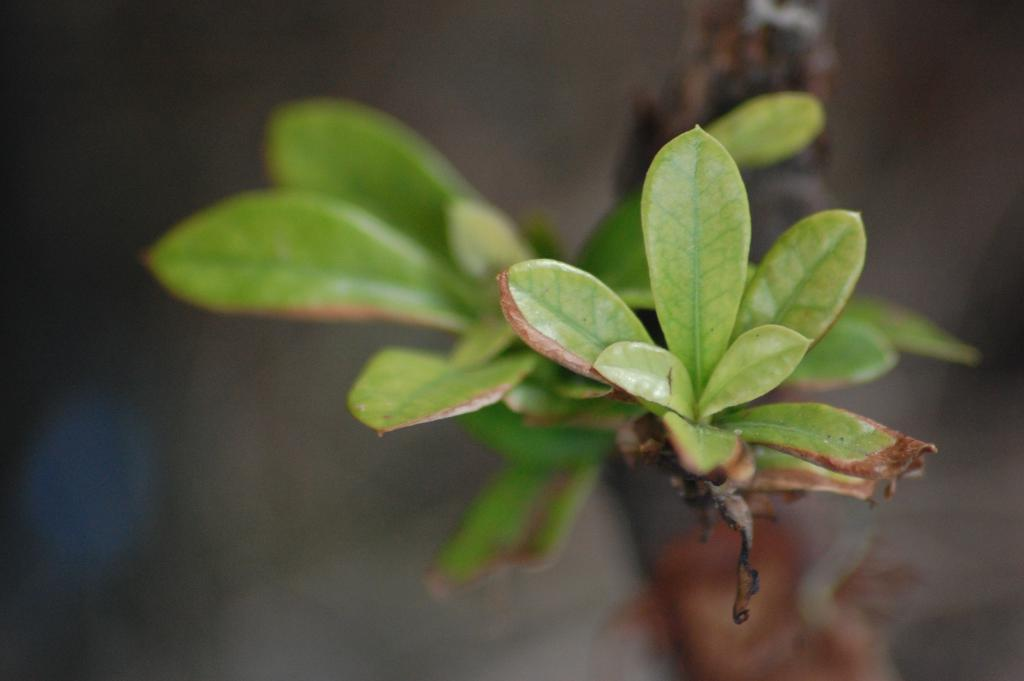What is present in the image? There is a plant in the image. What color is the plant? The plant is green in color. Can you describe the background of the image? The background of the image is blurred. How does the plant help with expansion in the image? The plant does not help with expansion in the image, as it is a static object and not involved in any expansion process. 